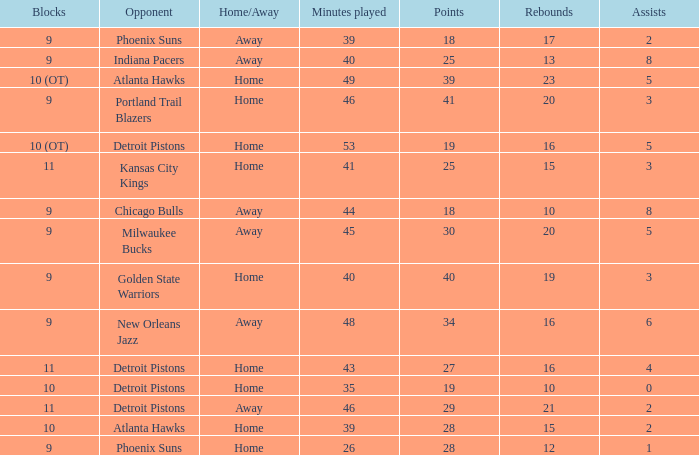Could you help me parse every detail presented in this table? {'header': ['Blocks', 'Opponent', 'Home/Away', 'Minutes played', 'Points', 'Rebounds', 'Assists'], 'rows': [['9', 'Phoenix Suns', 'Away', '39', '18', '17', '2'], ['9', 'Indiana Pacers', 'Away', '40', '25', '13', '8'], ['10 (OT)', 'Atlanta Hawks', 'Home', '49', '39', '23', '5'], ['9', 'Portland Trail Blazers', 'Home', '46', '41', '20', '3'], ['10 (OT)', 'Detroit Pistons', 'Home', '53', '19', '16', '5'], ['11', 'Kansas City Kings', 'Home', '41', '25', '15', '3'], ['9', 'Chicago Bulls', 'Away', '44', '18', '10', '8'], ['9', 'Milwaukee Bucks', 'Away', '45', '30', '20', '5'], ['9', 'Golden State Warriors', 'Home', '40', '40', '19', '3'], ['9', 'New Orleans Jazz', 'Away', '48', '34', '16', '6'], ['11', 'Detroit Pistons', 'Home', '43', '27', '16', '4'], ['10', 'Detroit Pistons', 'Home', '35', '19', '10', '0'], ['11', 'Detroit Pistons', 'Away', '46', '29', '21', '2'], ['10', 'Atlanta Hawks', 'Home', '39', '28', '15', '2'], ['9', 'Phoenix Suns', 'Home', '26', '28', '12', '1']]} How many minutes occurred when 18 points were achieved and the opposition was chicago bulls? 1.0. 